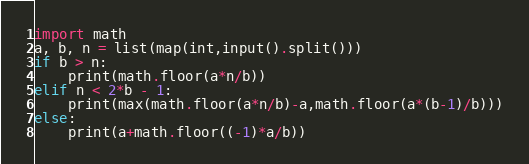<code> <loc_0><loc_0><loc_500><loc_500><_Python_>import math
a, b, n = list(map(int,input().split()))
if b > n:
    print(math.floor(a*n/b))
elif n < 2*b - 1:
    print(max(math.floor(a*n/b)-a,math.floor(a*(b-1)/b)))
else:
    print(a+math.floor((-1)*a/b))</code> 